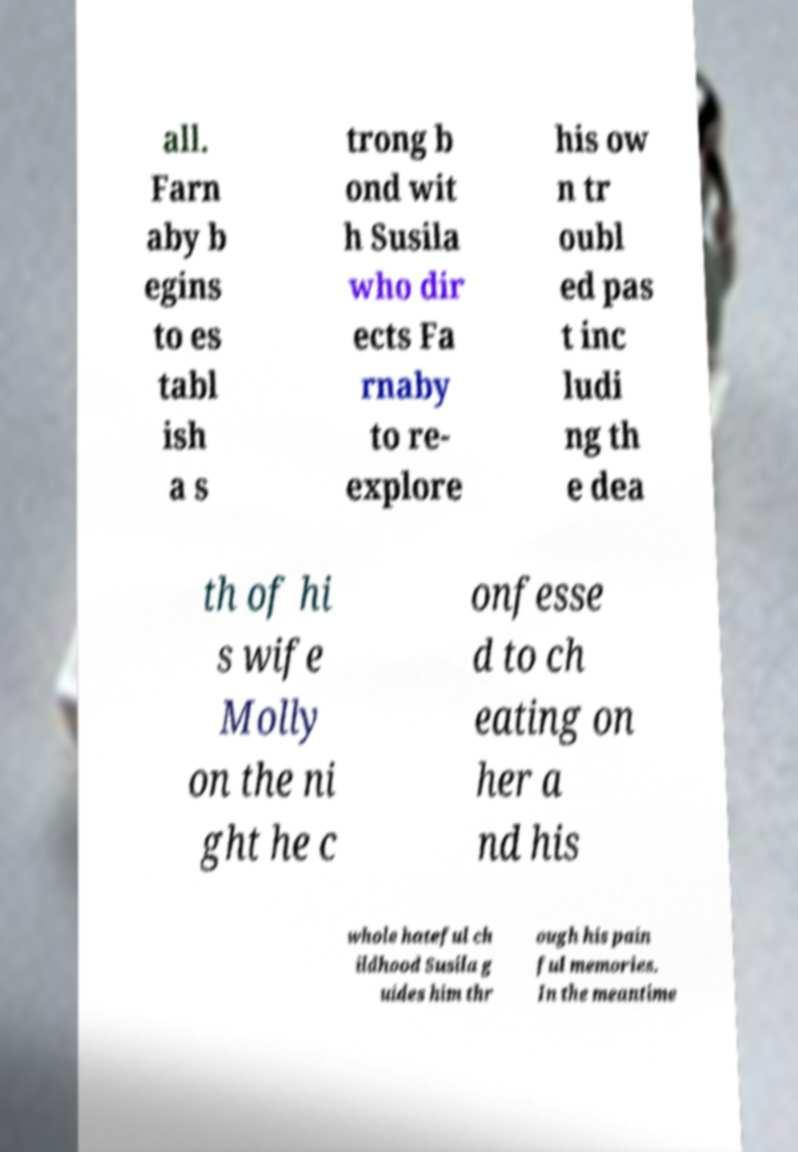Can you accurately transcribe the text from the provided image for me? all. Farn aby b egins to es tabl ish a s trong b ond wit h Susila who dir ects Fa rnaby to re- explore his ow n tr oubl ed pas t inc ludi ng th e dea th of hi s wife Molly on the ni ght he c onfesse d to ch eating on her a nd his whole hateful ch ildhood Susila g uides him thr ough his pain ful memories. In the meantime 